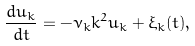<formula> <loc_0><loc_0><loc_500><loc_500>\frac { d u _ { k } } { d t } = - \nu _ { k } k ^ { 2 } u _ { k } + \xi _ { k } ( t ) ,</formula> 